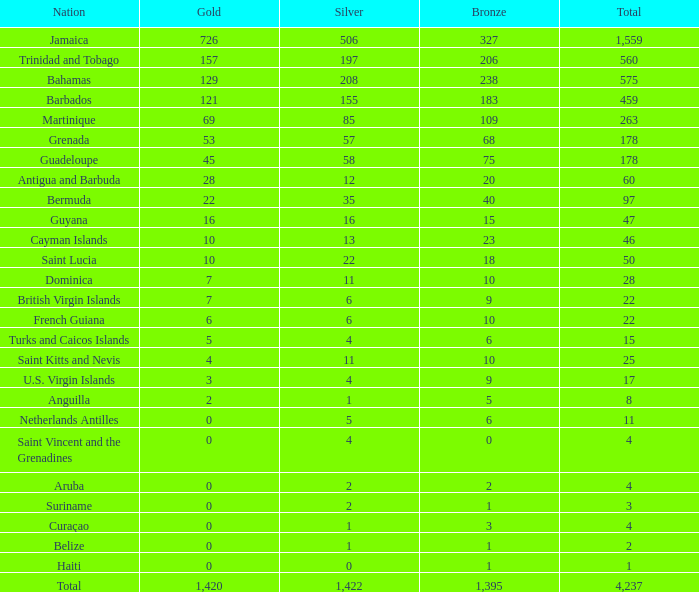What's the sum of Gold with a Bronze that's larger than 15, Silver that's smaller than 197, the Nation of Saint Lucia, and has a Total that is larger than 50? None. 